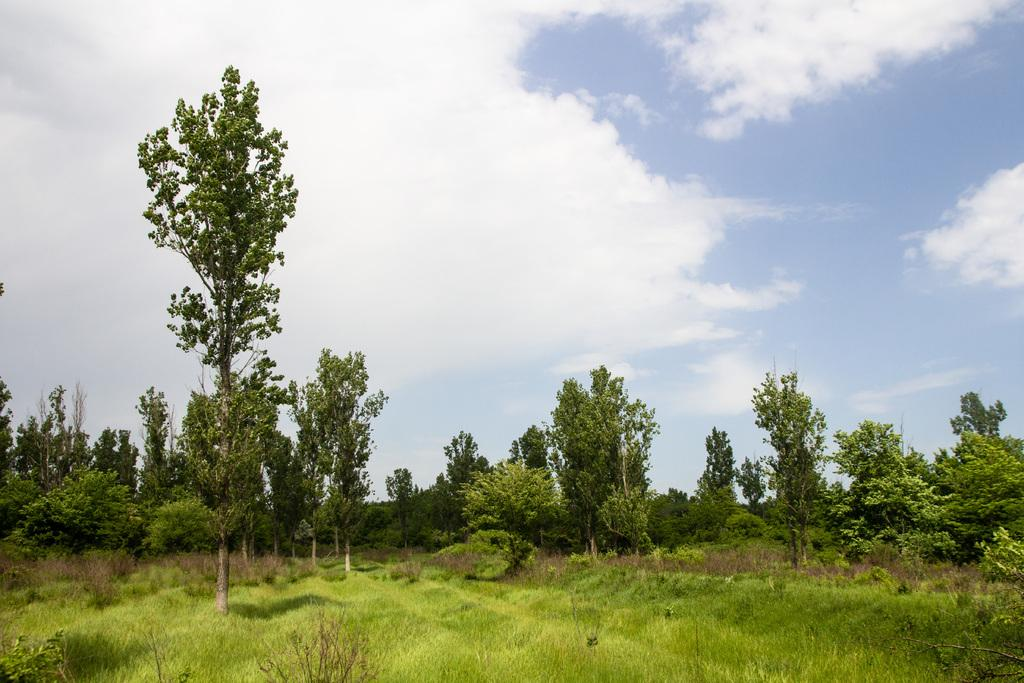What type of vegetation can be seen in the image? There is grass, plants, and trees in the image. What is visible in the background of the image? The sky is visible in the background of the image. What can be seen in the sky? Clouds are present in the sky. What type of grape is being used as a club in the image? There is no grape or club present in the image. 